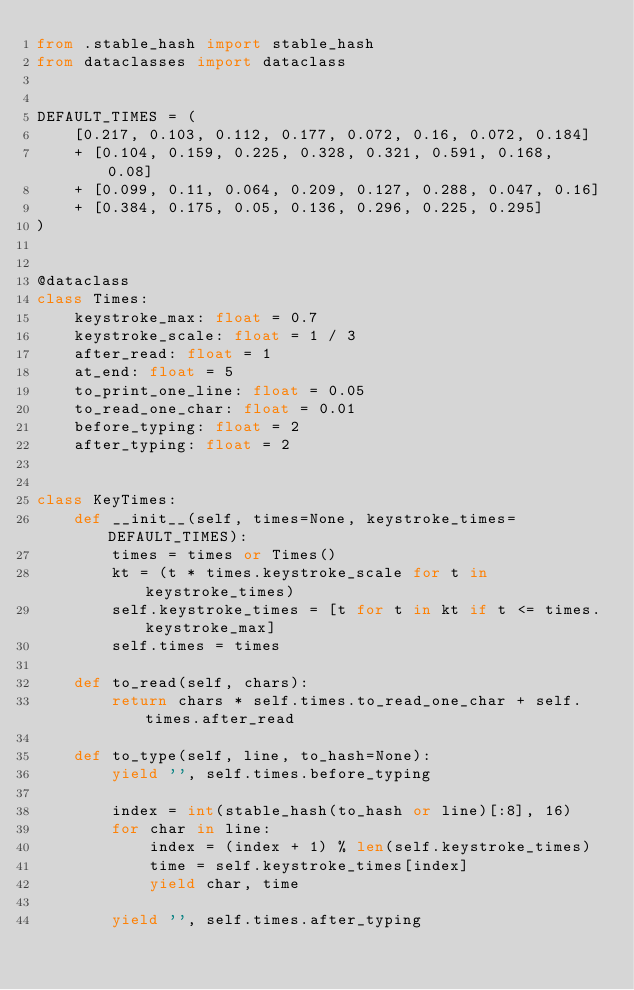<code> <loc_0><loc_0><loc_500><loc_500><_Python_>from .stable_hash import stable_hash
from dataclasses import dataclass


DEFAULT_TIMES = (
    [0.217, 0.103, 0.112, 0.177, 0.072, 0.16, 0.072, 0.184]
    + [0.104, 0.159, 0.225, 0.328, 0.321, 0.591, 0.168, 0.08]
    + [0.099, 0.11, 0.064, 0.209, 0.127, 0.288, 0.047, 0.16]
    + [0.384, 0.175, 0.05, 0.136, 0.296, 0.225, 0.295]
)


@dataclass
class Times:
    keystroke_max: float = 0.7
    keystroke_scale: float = 1 / 3
    after_read: float = 1
    at_end: float = 5
    to_print_one_line: float = 0.05
    to_read_one_char: float = 0.01
    before_typing: float = 2
    after_typing: float = 2


class KeyTimes:
    def __init__(self, times=None, keystroke_times=DEFAULT_TIMES):
        times = times or Times()
        kt = (t * times.keystroke_scale for t in keystroke_times)
        self.keystroke_times = [t for t in kt if t <= times.keystroke_max]
        self.times = times

    def to_read(self, chars):
        return chars * self.times.to_read_one_char + self.times.after_read

    def to_type(self, line, to_hash=None):
        yield '', self.times.before_typing

        index = int(stable_hash(to_hash or line)[:8], 16)
        for char in line:
            index = (index + 1) % len(self.keystroke_times)
            time = self.keystroke_times[index]
            yield char, time

        yield '', self.times.after_typing
</code> 